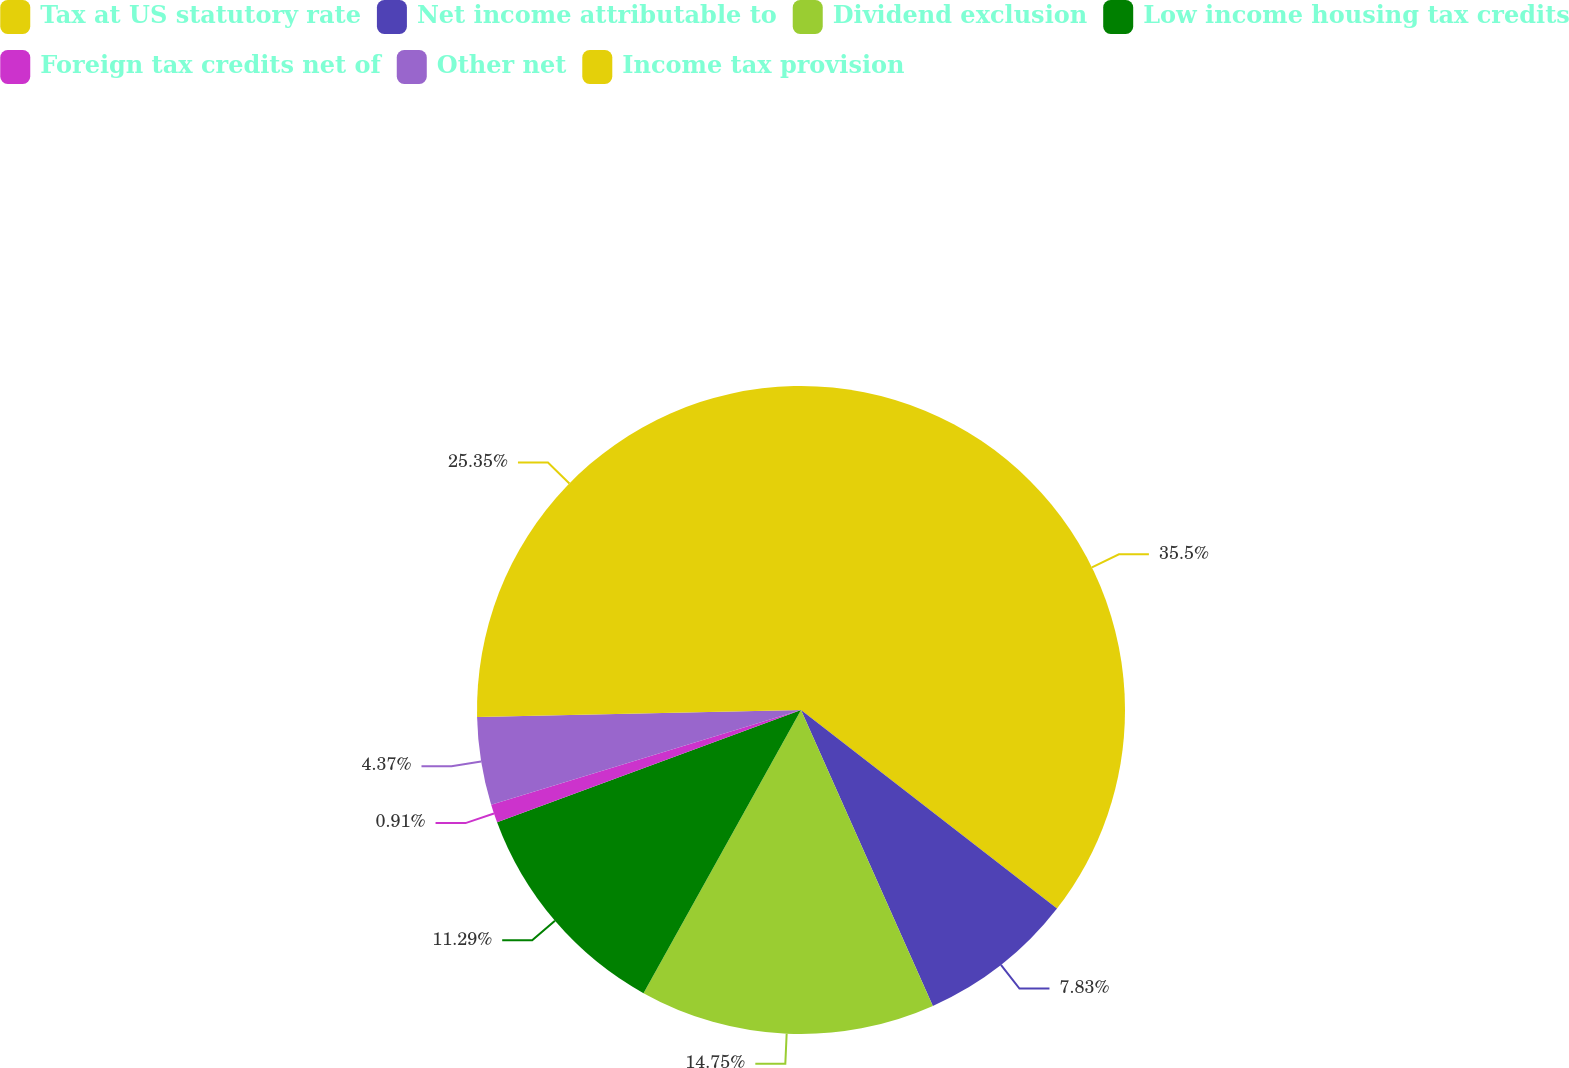Convert chart. <chart><loc_0><loc_0><loc_500><loc_500><pie_chart><fcel>Tax at US statutory rate<fcel>Net income attributable to<fcel>Dividend exclusion<fcel>Low income housing tax credits<fcel>Foreign tax credits net of<fcel>Other net<fcel>Income tax provision<nl><fcel>35.5%<fcel>7.83%<fcel>14.75%<fcel>11.29%<fcel>0.91%<fcel>4.37%<fcel>25.35%<nl></chart> 